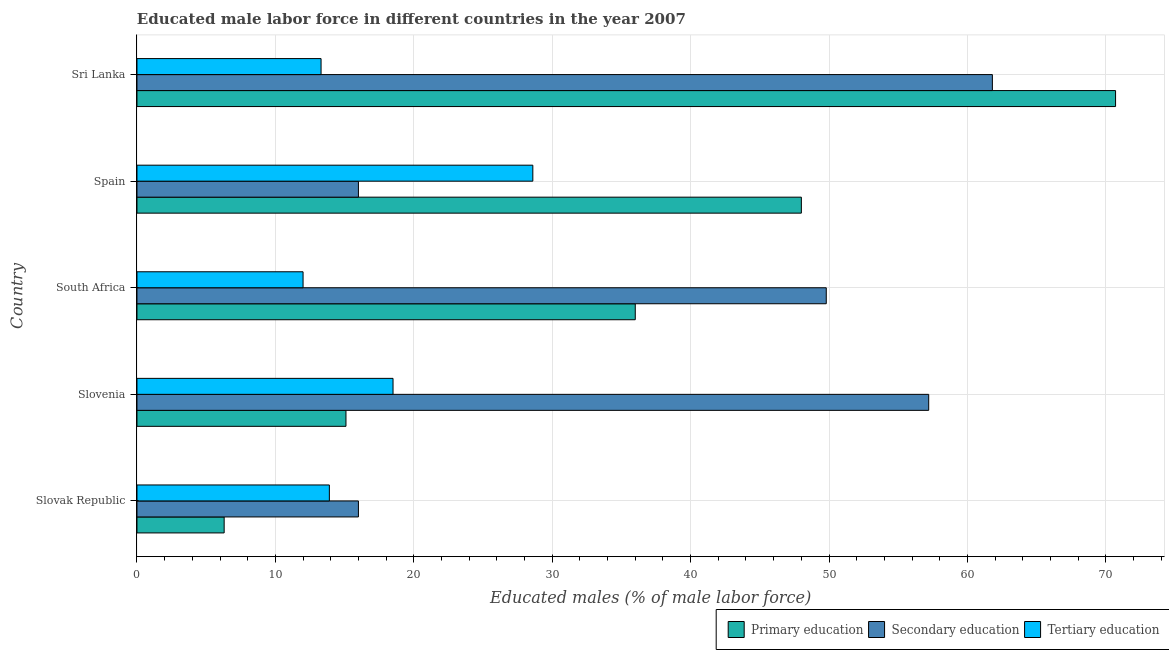How many different coloured bars are there?
Your answer should be compact. 3. How many groups of bars are there?
Make the answer very short. 5. Are the number of bars per tick equal to the number of legend labels?
Offer a very short reply. Yes. Are the number of bars on each tick of the Y-axis equal?
Ensure brevity in your answer.  Yes. How many bars are there on the 2nd tick from the top?
Keep it short and to the point. 3. What is the label of the 3rd group of bars from the top?
Ensure brevity in your answer.  South Africa. In how many cases, is the number of bars for a given country not equal to the number of legend labels?
Your answer should be very brief. 0. What is the percentage of male labor force who received tertiary education in Sri Lanka?
Provide a short and direct response. 13.3. Across all countries, what is the maximum percentage of male labor force who received tertiary education?
Your response must be concise. 28.6. In which country was the percentage of male labor force who received secondary education maximum?
Provide a short and direct response. Sri Lanka. In which country was the percentage of male labor force who received secondary education minimum?
Give a very brief answer. Slovak Republic. What is the total percentage of male labor force who received tertiary education in the graph?
Provide a succinct answer. 86.3. What is the difference between the percentage of male labor force who received primary education in Slovenia and that in South Africa?
Offer a very short reply. -20.9. What is the difference between the percentage of male labor force who received secondary education in South Africa and the percentage of male labor force who received tertiary education in Slovenia?
Provide a short and direct response. 31.3. What is the average percentage of male labor force who received secondary education per country?
Give a very brief answer. 40.16. What is the difference between the percentage of male labor force who received secondary education and percentage of male labor force who received tertiary education in Slovak Republic?
Provide a short and direct response. 2.1. In how many countries, is the percentage of male labor force who received primary education greater than 20 %?
Your answer should be compact. 3. What is the ratio of the percentage of male labor force who received primary education in South Africa to that in Sri Lanka?
Your response must be concise. 0.51. What is the difference between the highest and the lowest percentage of male labor force who received primary education?
Give a very brief answer. 64.4. Is the sum of the percentage of male labor force who received primary education in South Africa and Sri Lanka greater than the maximum percentage of male labor force who received tertiary education across all countries?
Make the answer very short. Yes. What does the 2nd bar from the top in Spain represents?
Your answer should be compact. Secondary education. What does the 2nd bar from the bottom in Slovenia represents?
Provide a short and direct response. Secondary education. How many countries are there in the graph?
Your response must be concise. 5. Does the graph contain any zero values?
Your answer should be very brief. No. Does the graph contain grids?
Offer a terse response. Yes. Where does the legend appear in the graph?
Offer a very short reply. Bottom right. How many legend labels are there?
Your answer should be very brief. 3. How are the legend labels stacked?
Offer a very short reply. Horizontal. What is the title of the graph?
Offer a terse response. Educated male labor force in different countries in the year 2007. Does "Labor Market" appear as one of the legend labels in the graph?
Ensure brevity in your answer.  No. What is the label or title of the X-axis?
Your response must be concise. Educated males (% of male labor force). What is the Educated males (% of male labor force) in Primary education in Slovak Republic?
Make the answer very short. 6.3. What is the Educated males (% of male labor force) of Tertiary education in Slovak Republic?
Ensure brevity in your answer.  13.9. What is the Educated males (% of male labor force) in Primary education in Slovenia?
Your answer should be very brief. 15.1. What is the Educated males (% of male labor force) in Secondary education in Slovenia?
Make the answer very short. 57.2. What is the Educated males (% of male labor force) in Primary education in South Africa?
Your response must be concise. 36. What is the Educated males (% of male labor force) of Secondary education in South Africa?
Your answer should be very brief. 49.8. What is the Educated males (% of male labor force) of Tertiary education in South Africa?
Provide a succinct answer. 12. What is the Educated males (% of male labor force) in Secondary education in Spain?
Ensure brevity in your answer.  16. What is the Educated males (% of male labor force) of Tertiary education in Spain?
Ensure brevity in your answer.  28.6. What is the Educated males (% of male labor force) in Primary education in Sri Lanka?
Ensure brevity in your answer.  70.7. What is the Educated males (% of male labor force) of Secondary education in Sri Lanka?
Your answer should be very brief. 61.8. What is the Educated males (% of male labor force) in Tertiary education in Sri Lanka?
Provide a succinct answer. 13.3. Across all countries, what is the maximum Educated males (% of male labor force) in Primary education?
Provide a succinct answer. 70.7. Across all countries, what is the maximum Educated males (% of male labor force) in Secondary education?
Your answer should be compact. 61.8. Across all countries, what is the maximum Educated males (% of male labor force) in Tertiary education?
Offer a terse response. 28.6. Across all countries, what is the minimum Educated males (% of male labor force) in Primary education?
Offer a very short reply. 6.3. Across all countries, what is the minimum Educated males (% of male labor force) in Secondary education?
Offer a terse response. 16. Across all countries, what is the minimum Educated males (% of male labor force) in Tertiary education?
Provide a succinct answer. 12. What is the total Educated males (% of male labor force) of Primary education in the graph?
Provide a short and direct response. 176.1. What is the total Educated males (% of male labor force) of Secondary education in the graph?
Your answer should be compact. 200.8. What is the total Educated males (% of male labor force) of Tertiary education in the graph?
Keep it short and to the point. 86.3. What is the difference between the Educated males (% of male labor force) in Secondary education in Slovak Republic and that in Slovenia?
Your answer should be compact. -41.2. What is the difference between the Educated males (% of male labor force) in Primary education in Slovak Republic and that in South Africa?
Offer a terse response. -29.7. What is the difference between the Educated males (% of male labor force) in Secondary education in Slovak Republic and that in South Africa?
Offer a terse response. -33.8. What is the difference between the Educated males (% of male labor force) in Tertiary education in Slovak Republic and that in South Africa?
Offer a terse response. 1.9. What is the difference between the Educated males (% of male labor force) of Primary education in Slovak Republic and that in Spain?
Offer a terse response. -41.7. What is the difference between the Educated males (% of male labor force) of Tertiary education in Slovak Republic and that in Spain?
Keep it short and to the point. -14.7. What is the difference between the Educated males (% of male labor force) of Primary education in Slovak Republic and that in Sri Lanka?
Provide a succinct answer. -64.4. What is the difference between the Educated males (% of male labor force) of Secondary education in Slovak Republic and that in Sri Lanka?
Offer a terse response. -45.8. What is the difference between the Educated males (% of male labor force) of Primary education in Slovenia and that in South Africa?
Keep it short and to the point. -20.9. What is the difference between the Educated males (% of male labor force) of Tertiary education in Slovenia and that in South Africa?
Offer a terse response. 6.5. What is the difference between the Educated males (% of male labor force) of Primary education in Slovenia and that in Spain?
Provide a short and direct response. -32.9. What is the difference between the Educated males (% of male labor force) in Secondary education in Slovenia and that in Spain?
Ensure brevity in your answer.  41.2. What is the difference between the Educated males (% of male labor force) of Primary education in Slovenia and that in Sri Lanka?
Offer a terse response. -55.6. What is the difference between the Educated males (% of male labor force) of Secondary education in Slovenia and that in Sri Lanka?
Provide a short and direct response. -4.6. What is the difference between the Educated males (% of male labor force) of Primary education in South Africa and that in Spain?
Offer a very short reply. -12. What is the difference between the Educated males (% of male labor force) of Secondary education in South Africa and that in Spain?
Your answer should be compact. 33.8. What is the difference between the Educated males (% of male labor force) of Tertiary education in South Africa and that in Spain?
Your answer should be very brief. -16.6. What is the difference between the Educated males (% of male labor force) of Primary education in South Africa and that in Sri Lanka?
Provide a succinct answer. -34.7. What is the difference between the Educated males (% of male labor force) in Primary education in Spain and that in Sri Lanka?
Keep it short and to the point. -22.7. What is the difference between the Educated males (% of male labor force) of Secondary education in Spain and that in Sri Lanka?
Your answer should be compact. -45.8. What is the difference between the Educated males (% of male labor force) in Primary education in Slovak Republic and the Educated males (% of male labor force) in Secondary education in Slovenia?
Provide a succinct answer. -50.9. What is the difference between the Educated males (% of male labor force) of Primary education in Slovak Republic and the Educated males (% of male labor force) of Tertiary education in Slovenia?
Offer a terse response. -12.2. What is the difference between the Educated males (% of male labor force) of Primary education in Slovak Republic and the Educated males (% of male labor force) of Secondary education in South Africa?
Provide a succinct answer. -43.5. What is the difference between the Educated males (% of male labor force) of Primary education in Slovak Republic and the Educated males (% of male labor force) of Tertiary education in South Africa?
Give a very brief answer. -5.7. What is the difference between the Educated males (% of male labor force) in Secondary education in Slovak Republic and the Educated males (% of male labor force) in Tertiary education in South Africa?
Ensure brevity in your answer.  4. What is the difference between the Educated males (% of male labor force) of Primary education in Slovak Republic and the Educated males (% of male labor force) of Secondary education in Spain?
Ensure brevity in your answer.  -9.7. What is the difference between the Educated males (% of male labor force) of Primary education in Slovak Republic and the Educated males (% of male labor force) of Tertiary education in Spain?
Keep it short and to the point. -22.3. What is the difference between the Educated males (% of male labor force) of Primary education in Slovak Republic and the Educated males (% of male labor force) of Secondary education in Sri Lanka?
Keep it short and to the point. -55.5. What is the difference between the Educated males (% of male labor force) of Primary education in Slovenia and the Educated males (% of male labor force) of Secondary education in South Africa?
Keep it short and to the point. -34.7. What is the difference between the Educated males (% of male labor force) in Secondary education in Slovenia and the Educated males (% of male labor force) in Tertiary education in South Africa?
Ensure brevity in your answer.  45.2. What is the difference between the Educated males (% of male labor force) in Primary education in Slovenia and the Educated males (% of male labor force) in Tertiary education in Spain?
Your answer should be very brief. -13.5. What is the difference between the Educated males (% of male labor force) in Secondary education in Slovenia and the Educated males (% of male labor force) in Tertiary education in Spain?
Provide a succinct answer. 28.6. What is the difference between the Educated males (% of male labor force) in Primary education in Slovenia and the Educated males (% of male labor force) in Secondary education in Sri Lanka?
Your response must be concise. -46.7. What is the difference between the Educated males (% of male labor force) of Secondary education in Slovenia and the Educated males (% of male labor force) of Tertiary education in Sri Lanka?
Your response must be concise. 43.9. What is the difference between the Educated males (% of male labor force) of Primary education in South Africa and the Educated males (% of male labor force) of Secondary education in Spain?
Provide a short and direct response. 20. What is the difference between the Educated males (% of male labor force) in Secondary education in South Africa and the Educated males (% of male labor force) in Tertiary education in Spain?
Provide a short and direct response. 21.2. What is the difference between the Educated males (% of male labor force) of Primary education in South Africa and the Educated males (% of male labor force) of Secondary education in Sri Lanka?
Offer a very short reply. -25.8. What is the difference between the Educated males (% of male labor force) of Primary education in South Africa and the Educated males (% of male labor force) of Tertiary education in Sri Lanka?
Provide a short and direct response. 22.7. What is the difference between the Educated males (% of male labor force) of Secondary education in South Africa and the Educated males (% of male labor force) of Tertiary education in Sri Lanka?
Your answer should be very brief. 36.5. What is the difference between the Educated males (% of male labor force) in Primary education in Spain and the Educated males (% of male labor force) in Tertiary education in Sri Lanka?
Provide a succinct answer. 34.7. What is the difference between the Educated males (% of male labor force) in Secondary education in Spain and the Educated males (% of male labor force) in Tertiary education in Sri Lanka?
Make the answer very short. 2.7. What is the average Educated males (% of male labor force) in Primary education per country?
Your answer should be compact. 35.22. What is the average Educated males (% of male labor force) in Secondary education per country?
Your response must be concise. 40.16. What is the average Educated males (% of male labor force) of Tertiary education per country?
Keep it short and to the point. 17.26. What is the difference between the Educated males (% of male labor force) of Primary education and Educated males (% of male labor force) of Tertiary education in Slovak Republic?
Provide a short and direct response. -7.6. What is the difference between the Educated males (% of male labor force) in Primary education and Educated males (% of male labor force) in Secondary education in Slovenia?
Ensure brevity in your answer.  -42.1. What is the difference between the Educated males (% of male labor force) of Primary education and Educated males (% of male labor force) of Tertiary education in Slovenia?
Provide a short and direct response. -3.4. What is the difference between the Educated males (% of male labor force) of Secondary education and Educated males (% of male labor force) of Tertiary education in Slovenia?
Offer a terse response. 38.7. What is the difference between the Educated males (% of male labor force) of Primary education and Educated males (% of male labor force) of Secondary education in South Africa?
Provide a short and direct response. -13.8. What is the difference between the Educated males (% of male labor force) in Primary education and Educated males (% of male labor force) in Tertiary education in South Africa?
Give a very brief answer. 24. What is the difference between the Educated males (% of male labor force) of Secondary education and Educated males (% of male labor force) of Tertiary education in South Africa?
Give a very brief answer. 37.8. What is the difference between the Educated males (% of male labor force) of Primary education and Educated males (% of male labor force) of Tertiary education in Spain?
Ensure brevity in your answer.  19.4. What is the difference between the Educated males (% of male labor force) of Primary education and Educated males (% of male labor force) of Tertiary education in Sri Lanka?
Offer a terse response. 57.4. What is the difference between the Educated males (% of male labor force) in Secondary education and Educated males (% of male labor force) in Tertiary education in Sri Lanka?
Ensure brevity in your answer.  48.5. What is the ratio of the Educated males (% of male labor force) of Primary education in Slovak Republic to that in Slovenia?
Offer a terse response. 0.42. What is the ratio of the Educated males (% of male labor force) in Secondary education in Slovak Republic to that in Slovenia?
Offer a terse response. 0.28. What is the ratio of the Educated males (% of male labor force) of Tertiary education in Slovak Republic to that in Slovenia?
Make the answer very short. 0.75. What is the ratio of the Educated males (% of male labor force) in Primary education in Slovak Republic to that in South Africa?
Your answer should be very brief. 0.17. What is the ratio of the Educated males (% of male labor force) in Secondary education in Slovak Republic to that in South Africa?
Offer a terse response. 0.32. What is the ratio of the Educated males (% of male labor force) in Tertiary education in Slovak Republic to that in South Africa?
Your answer should be very brief. 1.16. What is the ratio of the Educated males (% of male labor force) of Primary education in Slovak Republic to that in Spain?
Your response must be concise. 0.13. What is the ratio of the Educated males (% of male labor force) in Tertiary education in Slovak Republic to that in Spain?
Your answer should be compact. 0.49. What is the ratio of the Educated males (% of male labor force) of Primary education in Slovak Republic to that in Sri Lanka?
Offer a very short reply. 0.09. What is the ratio of the Educated males (% of male labor force) of Secondary education in Slovak Republic to that in Sri Lanka?
Your response must be concise. 0.26. What is the ratio of the Educated males (% of male labor force) of Tertiary education in Slovak Republic to that in Sri Lanka?
Provide a short and direct response. 1.05. What is the ratio of the Educated males (% of male labor force) of Primary education in Slovenia to that in South Africa?
Offer a very short reply. 0.42. What is the ratio of the Educated males (% of male labor force) of Secondary education in Slovenia to that in South Africa?
Make the answer very short. 1.15. What is the ratio of the Educated males (% of male labor force) in Tertiary education in Slovenia to that in South Africa?
Offer a terse response. 1.54. What is the ratio of the Educated males (% of male labor force) of Primary education in Slovenia to that in Spain?
Give a very brief answer. 0.31. What is the ratio of the Educated males (% of male labor force) of Secondary education in Slovenia to that in Spain?
Keep it short and to the point. 3.58. What is the ratio of the Educated males (% of male labor force) of Tertiary education in Slovenia to that in Spain?
Keep it short and to the point. 0.65. What is the ratio of the Educated males (% of male labor force) of Primary education in Slovenia to that in Sri Lanka?
Your answer should be compact. 0.21. What is the ratio of the Educated males (% of male labor force) of Secondary education in Slovenia to that in Sri Lanka?
Offer a terse response. 0.93. What is the ratio of the Educated males (% of male labor force) in Tertiary education in Slovenia to that in Sri Lanka?
Ensure brevity in your answer.  1.39. What is the ratio of the Educated males (% of male labor force) of Secondary education in South Africa to that in Spain?
Provide a succinct answer. 3.11. What is the ratio of the Educated males (% of male labor force) of Tertiary education in South Africa to that in Spain?
Give a very brief answer. 0.42. What is the ratio of the Educated males (% of male labor force) in Primary education in South Africa to that in Sri Lanka?
Your response must be concise. 0.51. What is the ratio of the Educated males (% of male labor force) in Secondary education in South Africa to that in Sri Lanka?
Your answer should be very brief. 0.81. What is the ratio of the Educated males (% of male labor force) of Tertiary education in South Africa to that in Sri Lanka?
Give a very brief answer. 0.9. What is the ratio of the Educated males (% of male labor force) in Primary education in Spain to that in Sri Lanka?
Keep it short and to the point. 0.68. What is the ratio of the Educated males (% of male labor force) of Secondary education in Spain to that in Sri Lanka?
Provide a short and direct response. 0.26. What is the ratio of the Educated males (% of male labor force) in Tertiary education in Spain to that in Sri Lanka?
Give a very brief answer. 2.15. What is the difference between the highest and the second highest Educated males (% of male labor force) in Primary education?
Your answer should be very brief. 22.7. What is the difference between the highest and the second highest Educated males (% of male labor force) of Tertiary education?
Offer a terse response. 10.1. What is the difference between the highest and the lowest Educated males (% of male labor force) in Primary education?
Provide a short and direct response. 64.4. What is the difference between the highest and the lowest Educated males (% of male labor force) of Secondary education?
Your response must be concise. 45.8. What is the difference between the highest and the lowest Educated males (% of male labor force) of Tertiary education?
Provide a succinct answer. 16.6. 